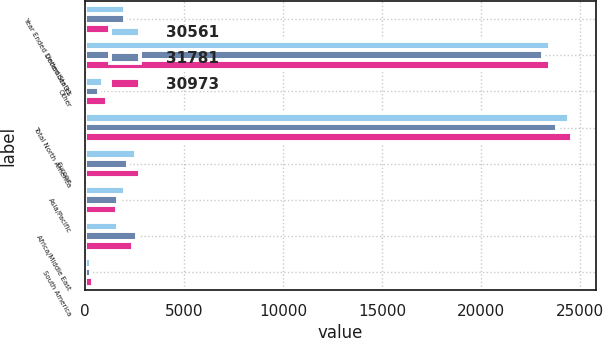Convert chart to OTSL. <chart><loc_0><loc_0><loc_500><loc_500><stacked_bar_chart><ecel><fcel>Year Ended December 31<fcel>United States<fcel>Other<fcel>Total North America<fcel>Europe<fcel>Asia/Pacific<fcel>Africa/Middle East<fcel>South America<nl><fcel>30561<fcel>2017<fcel>23519<fcel>915<fcel>24434<fcel>2558<fcel>2011<fcel>1655<fcel>315<nl><fcel>31781<fcel>2016<fcel>23160<fcel>709<fcel>23869<fcel>2152<fcel>1650<fcel>2617<fcel>273<nl><fcel>30973<fcel>2015<fcel>23480<fcel>1121<fcel>24601<fcel>2760<fcel>1589<fcel>2426<fcel>405<nl></chart> 